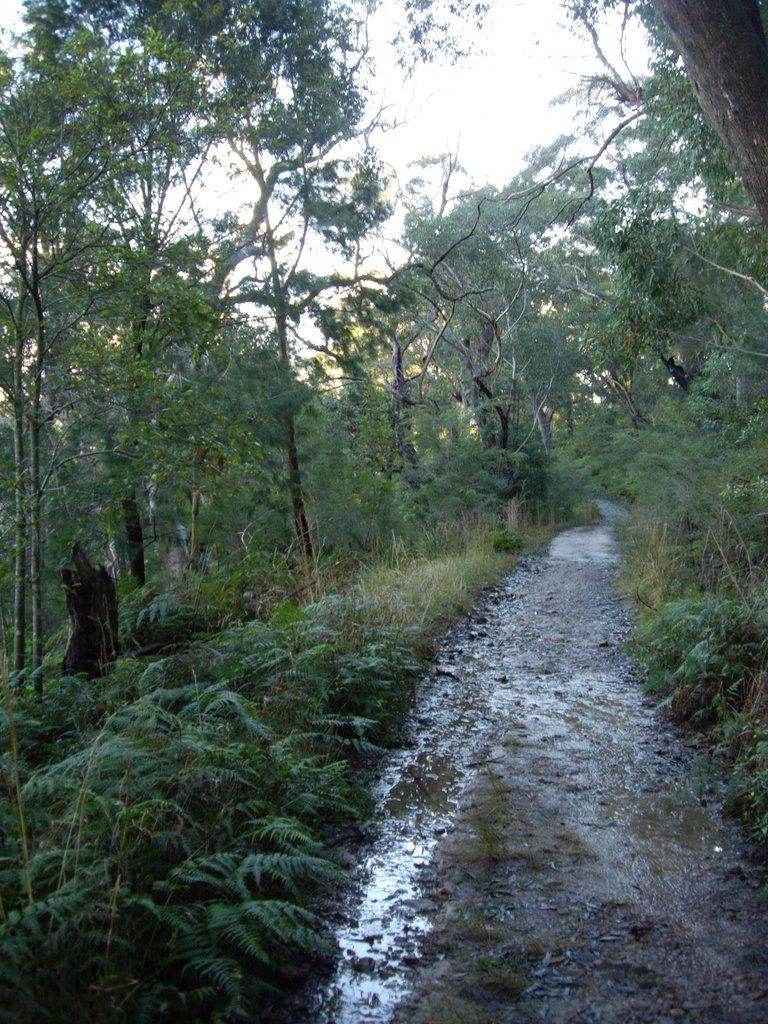What is the dominant color or feature in the image? There is a lot of greenery in the image. Can you describe any paths or walkways in the image? There is a small walkway in the image. How does the walkway appear in the image? The walkway is wet in the image. Is there any indication of the weather or environment in the image? There is slight moisture on the walkway, which suggests a damp or wet environment. What type of canvas is being used to create the image? The facts provided do not mention a canvas or any medium used to create the image. --- Facts: 1. There is a person sitting on a bench in the image. 2. The person is reading a book. 3. The bench is located near a tree. 4. The tree has leaves. 5. The person is wearing a hat. Absurd Topics: parrot, bicycle, ocean Conversation: What is the person in the image doing? The person in the image is sitting on a bench and reading a book. Where is the bench located in the image? The bench is located near a tree in the image. Can you describe the tree in the image? The tree has leaves in the image. What is the person wearing in the image? The person is wearing a hat in the image. Reasoning: Let's think step by step in order to produce the conversation. We start by identifying the main subject in the image, which is the person sitting on the bench. Then, we describe what the person is doing, which is reading a book. Next, we provide information about the location of the bench, which is near a tree. Finally, we mention the person's attire, specifically the hat they are wearing. Absurd Question/Answer: Can you see any parrots sitting on the bicycle near the ocean in the image? There is no mention of a bicycle, parrots, or the ocean in the provided facts, so these elements are not present in the image. 